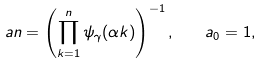<formula> <loc_0><loc_0><loc_500><loc_500>\ a n = \left ( \prod _ { k = 1 } ^ { n } \psi _ { \gamma } ( \alpha k ) \right ) ^ { - 1 } , \quad a _ { 0 } = 1 ,</formula> 